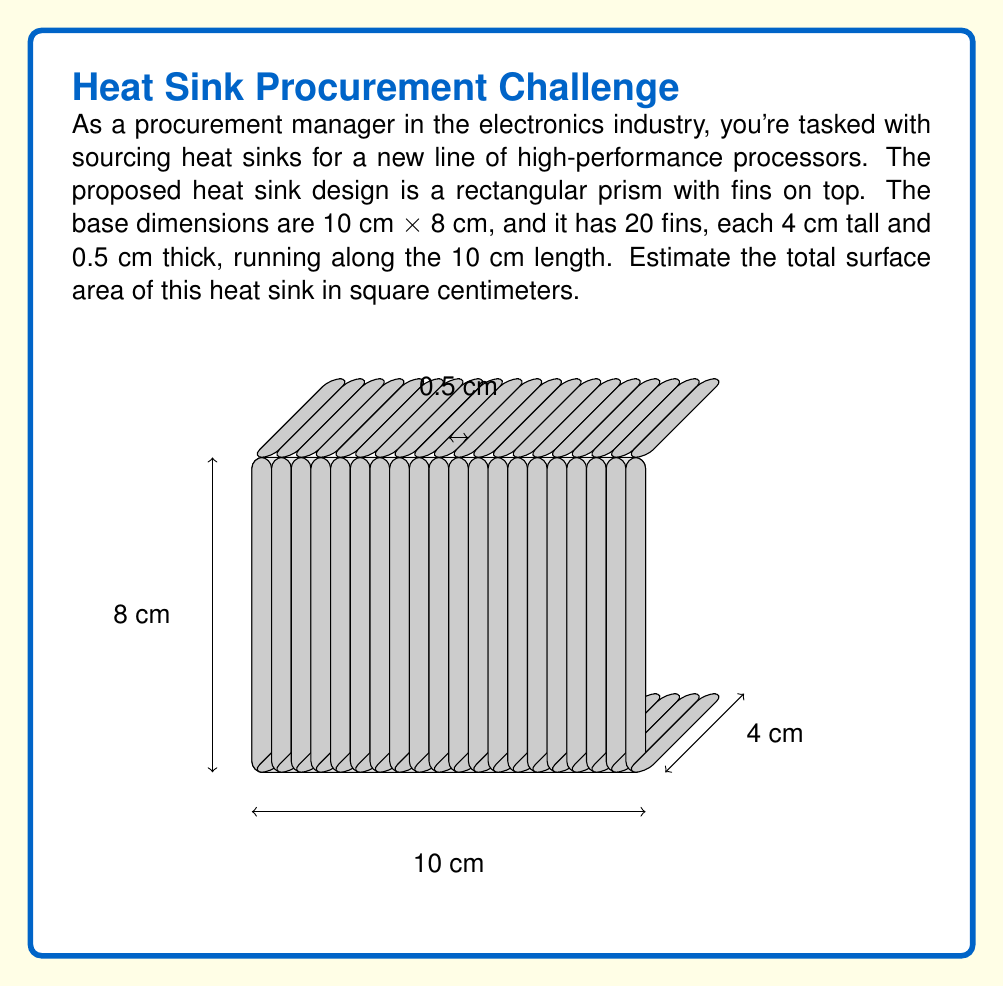Help me with this question. Let's break this down step-by-step:

1) First, calculate the surface area of the base:
   - Top and bottom: $2 \times (10 \text{ cm} \times 8 \text{ cm}) = 160 \text{ cm}^2$
   - Sides: $2 \times (10 \text{ cm} \times 0.5 \text{ cm}) + 2 \times (8 \text{ cm} \times 0.5 \text{ cm}) = 18 \text{ cm}^2$
   Base total: $160 + 18 = 178 \text{ cm}^2$

2) Now, calculate the surface area of each fin:
   - Two large sides: $2 \times (4 \text{ cm} \times 8 \text{ cm}) = 64 \text{ cm}^2$
   - Top: $1 \times (0.5 \text{ cm} \times 8 \text{ cm}) = 4 \text{ cm}^2$
   - Small end: $1 \times (0.5 \text{ cm} \times 4 \text{ cm}) = 2 \text{ cm}^2$
   Per fin total: $64 + 4 + 2 = 70 \text{ cm}^2$

3) Calculate the total surface area of all fins:
   $20 \text{ fins} \times 70 \text{ cm}^2 = 1400 \text{ cm}^2$

4) The area where the fins connect to the base is counted twice, so we need to subtract it:
   $20 \text{ fins} \times (0.5 \text{ cm} \times 8 \text{ cm}) = 80 \text{ cm}^2$

5) Sum up the total surface area:
   Total = Base + All fins - Overlapping area
   $$A_{\text{total}} = 178 \text{ cm}^2 + 1400 \text{ cm}^2 - 80 \text{ cm}^2 = 1498 \text{ cm}^2$$
Answer: 1498 cm² 